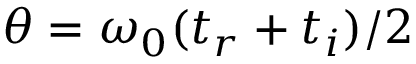Convert formula to latex. <formula><loc_0><loc_0><loc_500><loc_500>\theta = \omega _ { 0 } ( t _ { r } + t _ { i } ) / 2</formula> 